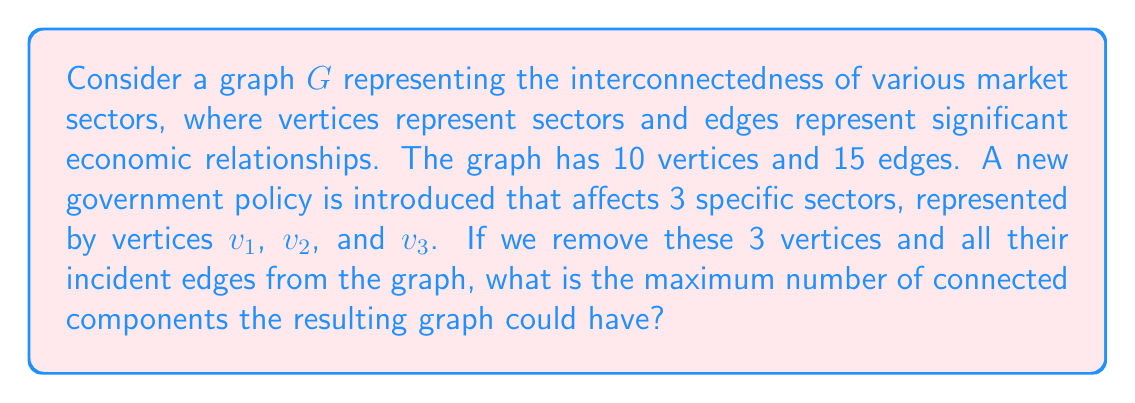Give your solution to this math problem. To solve this problem, we need to consider the following steps:

1) Initially, we have a graph $G$ with $|V(G)| = 10$ vertices and $|E(G)| = 15$ edges.

2) We are removing 3 vertices ($v_1$, $v_2$, and $v_3$) and all their incident edges. Let's call the resulting graph $G'$.

3) The number of vertices in $G'$ is $|V(G')| = 10 - 3 = 7$.

4) To maximize the number of connected components in $G'$, we need to remove as many edges as possible when removing $v_1$, $v_2$, and $v_3$.

5) The maximum number of edges that can be removed is when $v_1$, $v_2$, and $v_3$ form a triangle and each is connected to every other vertex in the graph. In this case:
   - 3 edges for the triangle
   - 3 * 7 = 21 edges connecting to other vertices
   - Total: 24 edges

6) However, we only have 15 edges in total. So we will remove all 15 edges.

7) In the extreme case, this leaves $G'$ with 7 isolated vertices.

8) The number of connected components in a graph is equal to the number of isolated vertices plus the number of non-trivial connected components.

Therefore, the maximum number of connected components in $G'$ is 7, which occurs when all 7 remaining vertices are isolated.

This scenario aligns with the persona of a critic who believes in the strong influence of external factors (like government policies) on market trends, as the removal of just three sectors due to a policy change could potentially disconnect all market sectors in this model.
Answer: 7 connected components 